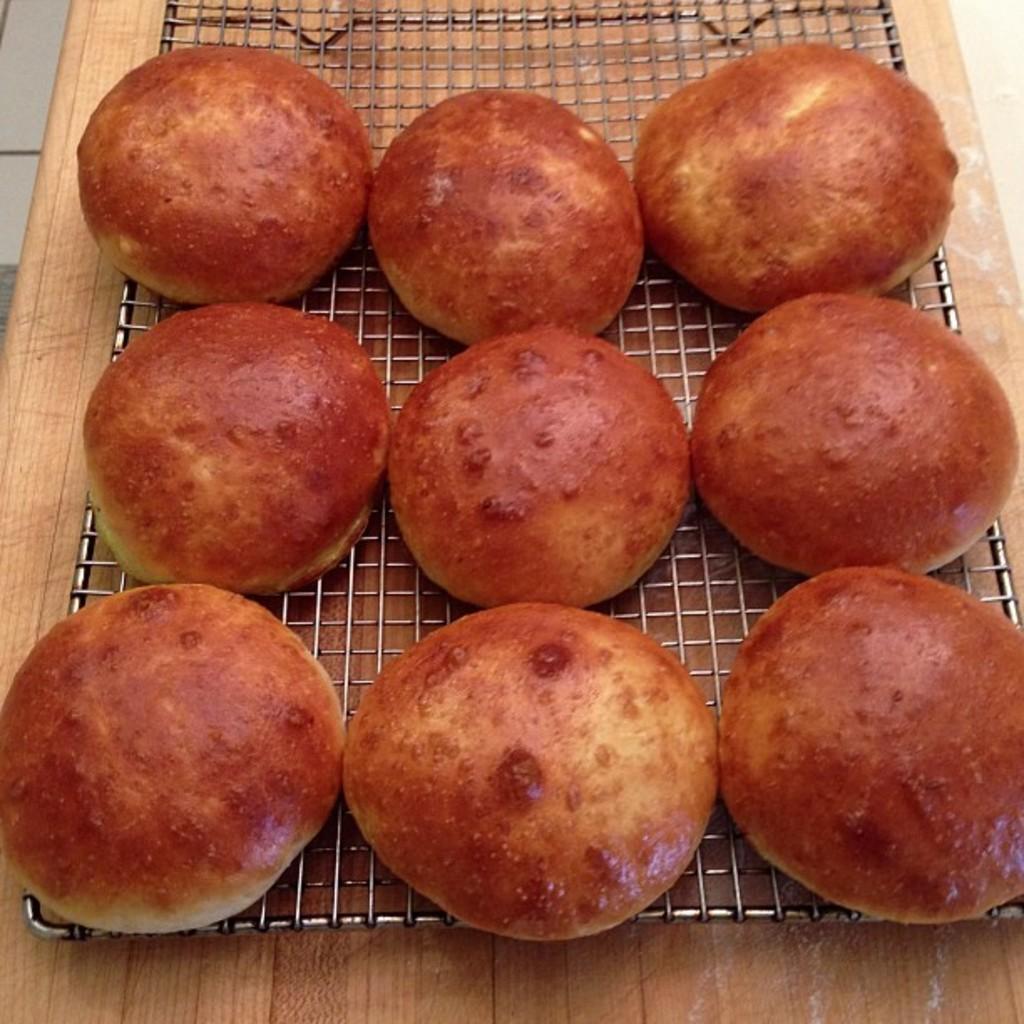How would you summarize this image in a sentence or two? There are 9 hot buns on the grill. 